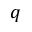<formula> <loc_0><loc_0><loc_500><loc_500>q</formula> 